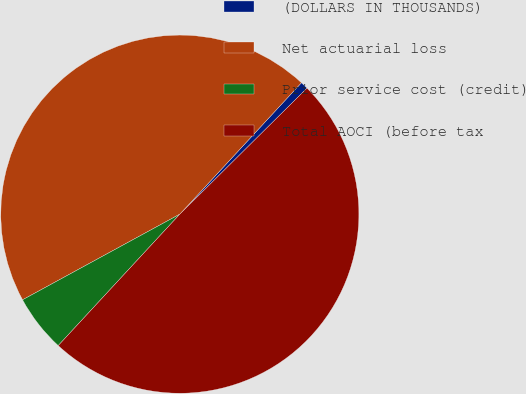Convert chart. <chart><loc_0><loc_0><loc_500><loc_500><pie_chart><fcel>(DOLLARS IN THOUSANDS)<fcel>Net actuarial loss<fcel>Prior service cost (credit)<fcel>Total AOCI (before tax<nl><fcel>0.69%<fcel>44.82%<fcel>5.18%<fcel>49.31%<nl></chart> 